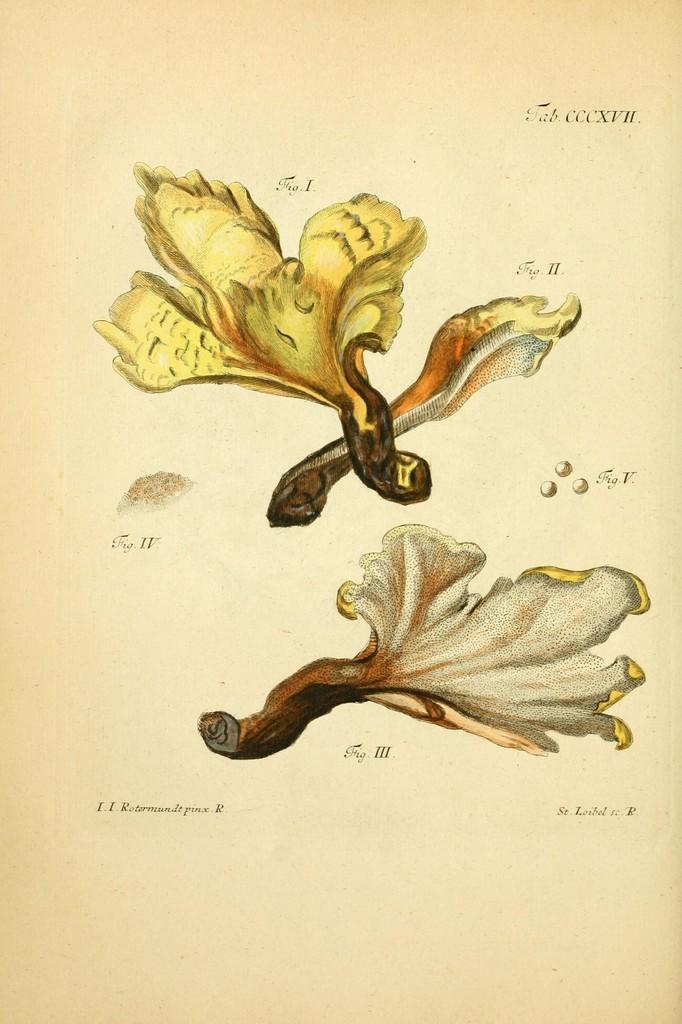What is depicted in the paintings in the image? There are paintings of three leaves in the image. What is the background color of the paintings? The paintings are on a white paper. Are there any words or letters in the image? Yes, there is some text in the image. What type of toothbrush is shown in the image? There is no toothbrush present in the image. How many hours did the person depicted in the image sleep last night? There is no person or indication of sleep in the image. 